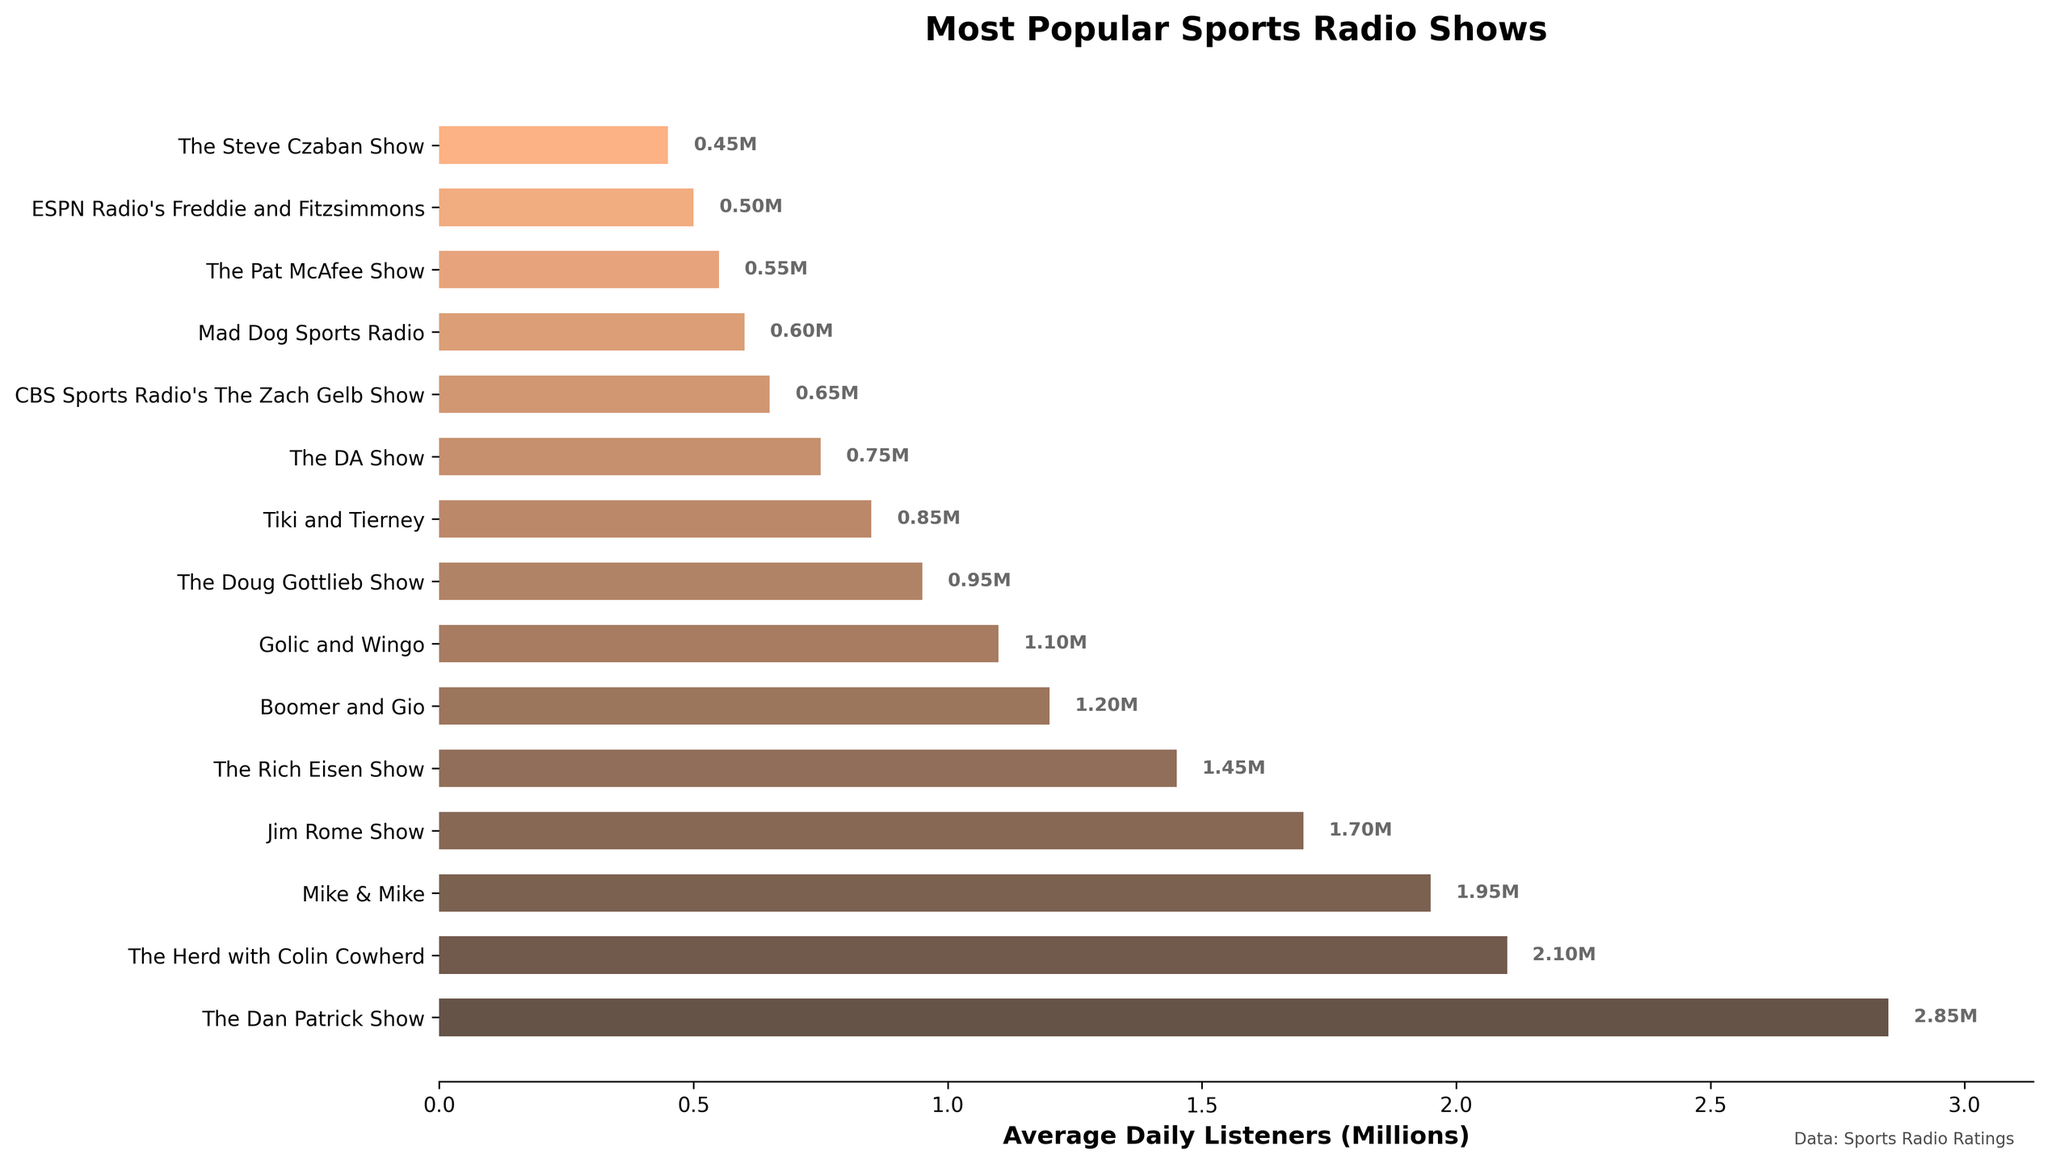Which radio show has the highest average daily listeners? The bar with the longest length represents the show with the highest average daily listeners. "The Dan Patrick Show" has the longest bar, representing 2.85 million listeners.
Answer: The Dan Patrick Show Which two shows have the smallest difference in average daily listeners? Look for two bars with lengths that are closest together. "Golic and Wingo" (1.1M) and "The Doug Gottlieb Show" (0.95M) have the smallest difference of 0.15 million listeners.
Answer: Golic and Wingo and The Doug Gottlieb Show How many shows have more than 1 million average daily listeners? Count the number of bars that extend beyond the 1 million mark on the x-axis. There are seven shows above this threshold.
Answer: 7 Which show has fewer listeners, "The Pat McAfee Show" or "Mad Dog Sports Radio," and by how much? Compare the lengths of the bars for both shows. "Mad Dog Sports Radio" (0.60M) has 0.05 million more listeners than "The Pat McAfee Show" (0.55M), so "The Pat McAfee Show" has fewer listeners by 0.05 million.
Answer: The Pat McAfee Show, 0.05M What is the average number of listeners for "Mike & Mike" and "Boomer and Gio"? Average is calculated by summing the listeners of the two shows and dividing by 2. "Mike & Mike" has 1.95 million listeners and "Boomer and Gio" has 1.2 million listeners. (1.95 + 1.2) / 2 = 1.575 million listeners.
Answer: 1.575M Which show has the closest number of average daily listeners to 1 million? Find the bar length closest to the 1 million mark on the x-axis. "Golic and Wingo" has 1.1 million listeners, which is the closest to 1 million.
Answer: Golic and Wingo What is the total number of listeners for the top three most popular shows? Sum the bars for the top three shows. "The Dan Patrick Show" (2.85M), "The Herd with Colin Cowherd" (2.1M), and "Mike & Mike" (1.95M). 2.85 + 2.1 + 1.95 = 6.9 million listeners.
Answer: 6.9M Which show has slightly more listeners than "The Rich Eisen Show"? Look for the bar just above "The Rich Eisen Show" (1.45M) in the figure. "Jim Rome Show" has slightly more listeners with 1.7 million.
Answer: Jim Rome Show What is the difference in average daily listeners between the most and least popular shows? Subtract the number of listeners of the least popular show ("The Steve Czaban Show" with 0.45M) from the most popular show ("The Dan Patrick Show" with 2.85M). 2.85 - 0.45 = 2.4 million listeners.
Answer: 2.4M Which shows have listener counts between 1 million and 2 million? Identify the bars that fall within this range. "Mike & Mike" (1.95M), "Jim Rome Show" (1.7M), "The Rich Eisen Show" (1.45M), and "Boomer and Gio" (1.2M).
Answer: Mike & Mike, Jim Rome Show, The Rich Eisen Show, Boomer and Gio 